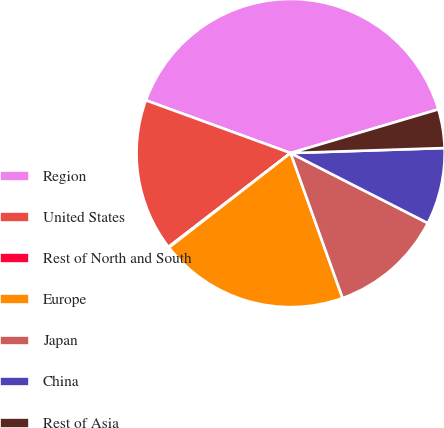Convert chart to OTSL. <chart><loc_0><loc_0><loc_500><loc_500><pie_chart><fcel>Region<fcel>United States<fcel>Rest of North and South<fcel>Europe<fcel>Japan<fcel>China<fcel>Rest of Asia<nl><fcel>39.86%<fcel>15.99%<fcel>0.08%<fcel>19.97%<fcel>12.01%<fcel>8.03%<fcel>4.06%<nl></chart> 